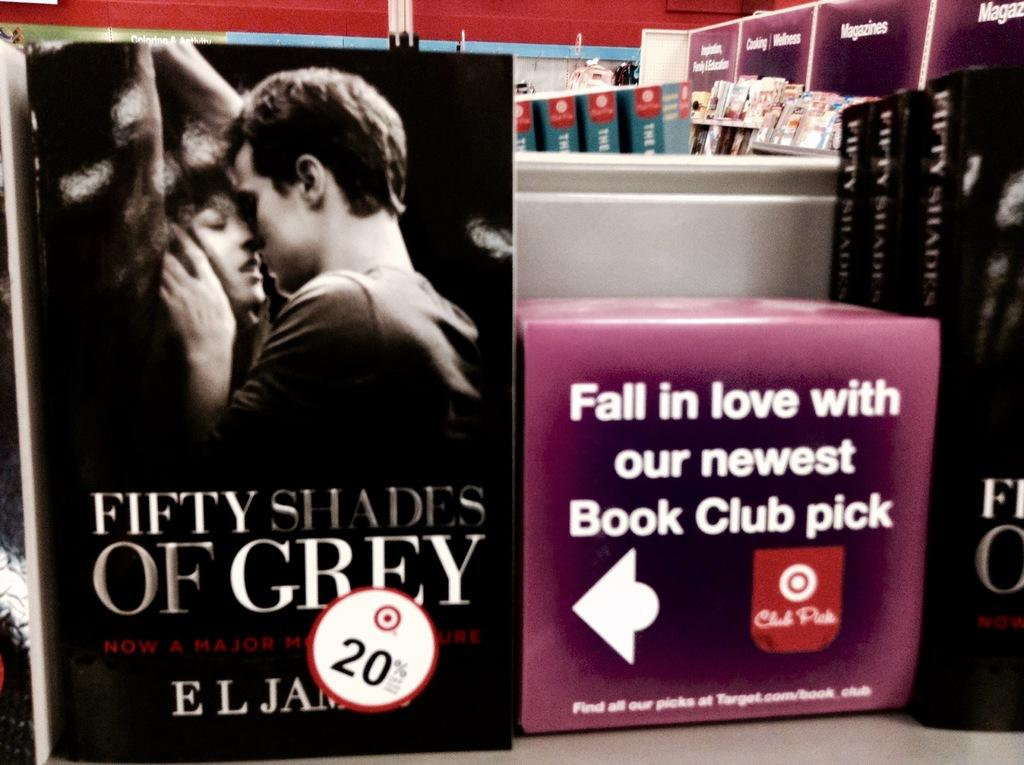<image>
Present a compact description of the photo's key features. A book cover of the book Fifty Shades of Grey. 